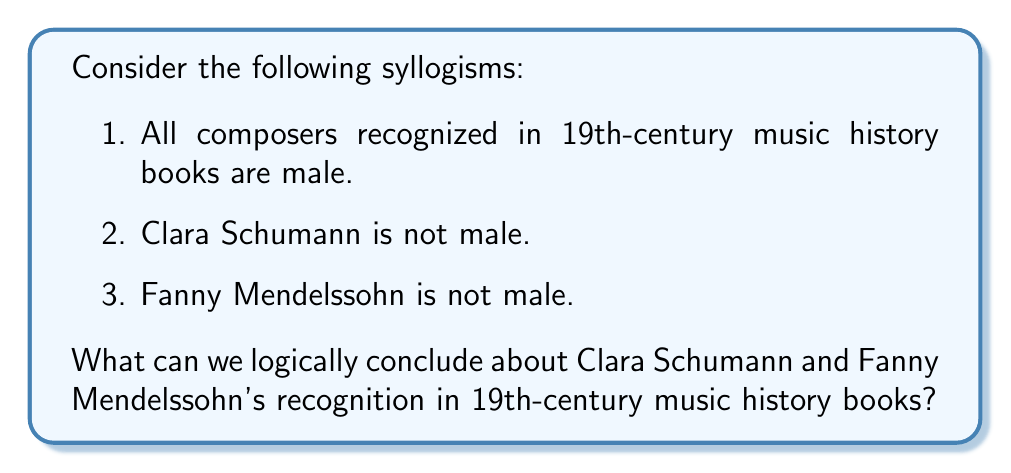Can you solve this math problem? Let's approach this step-by-step using the principles of syllogistic reasoning:

1. First, let's formalize the given syllogisms:
   
   Premise 1: $\forall x (R(x) \rightarrow M(x))$
   Where $R(x)$ means "x is recognized in 19th-century music history books" and $M(x)$ means "x is male"
   
   Premise 2: $\neg M(C)$
   Where $C$ represents Clara Schumann
   
   Premise 3: $\neg M(F)$
   Where $F$ represents Fanny Mendelssohn

2. Now, we can use the law of contraposition on Premise 1:
   $\forall x (R(x) \rightarrow M(x))$ is logically equivalent to $\forall x (\neg M(x) \rightarrow \neg R(x))$

3. Applying this to Clara Schumann:
   $\neg M(C) \rightarrow \neg R(C)$
   
   We know $\neg M(C)$ from Premise 2, so we can conclude $\neg R(C)$

4. Similarly for Fanny Mendelssohn:
   $\neg M(F) \rightarrow \neg R(F)$
   
   We know $\neg M(F)$ from Premise 3, so we can conclude $\neg R(F)$

5. Therefore, we can logically conclude that neither Clara Schumann nor Fanny Mendelssohn are recognized in 19th-century music history books.

This syllogistic reasoning highlights the historical underrepresentation of female composers in traditional music history narratives, aligning with the persona's interest in overlooked female composers.
Answer: Based on the given syllogisms, we can logically conclude that neither Clara Schumann nor Fanny Mendelssohn are recognized in 19th-century music history books. 